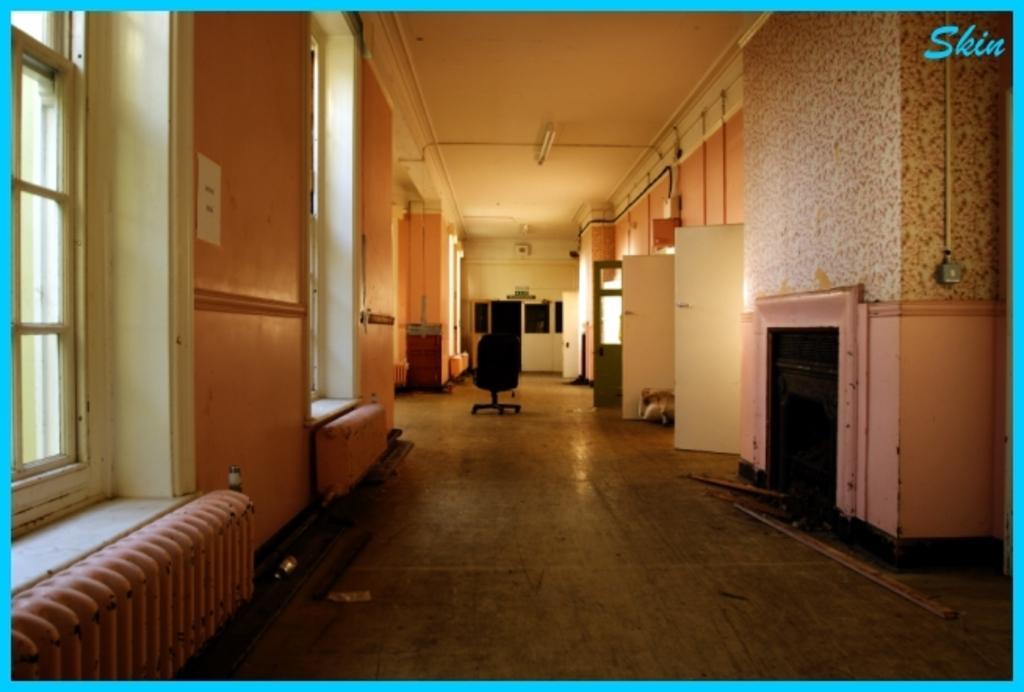In one or two sentences, can you explain what this image depicts? In this image we can see the windows, doors, wall, fireplace and also a chair on the floor. We can also see the lights attached to the ceiling. In the top right corner we can see the text and the image has blue color borders. 